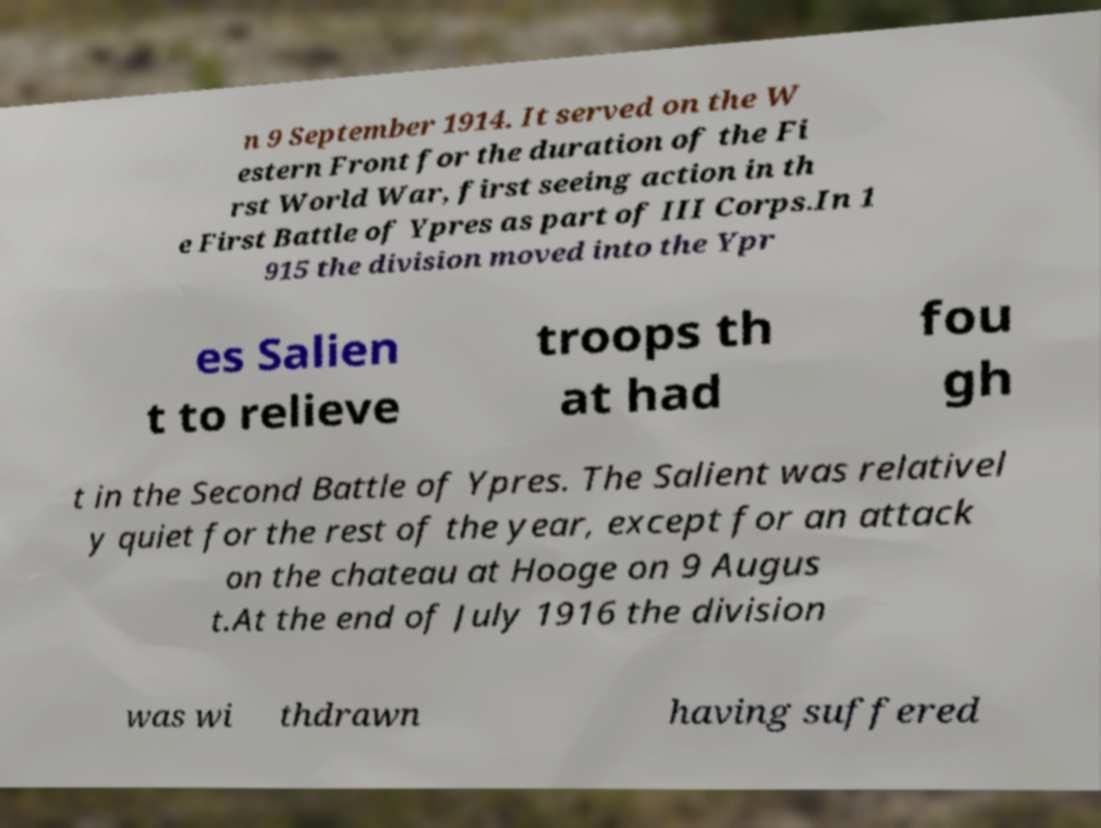Could you assist in decoding the text presented in this image and type it out clearly? n 9 September 1914. It served on the W estern Front for the duration of the Fi rst World War, first seeing action in th e First Battle of Ypres as part of III Corps.In 1 915 the division moved into the Ypr es Salien t to relieve troops th at had fou gh t in the Second Battle of Ypres. The Salient was relativel y quiet for the rest of the year, except for an attack on the chateau at Hooge on 9 Augus t.At the end of July 1916 the division was wi thdrawn having suffered 